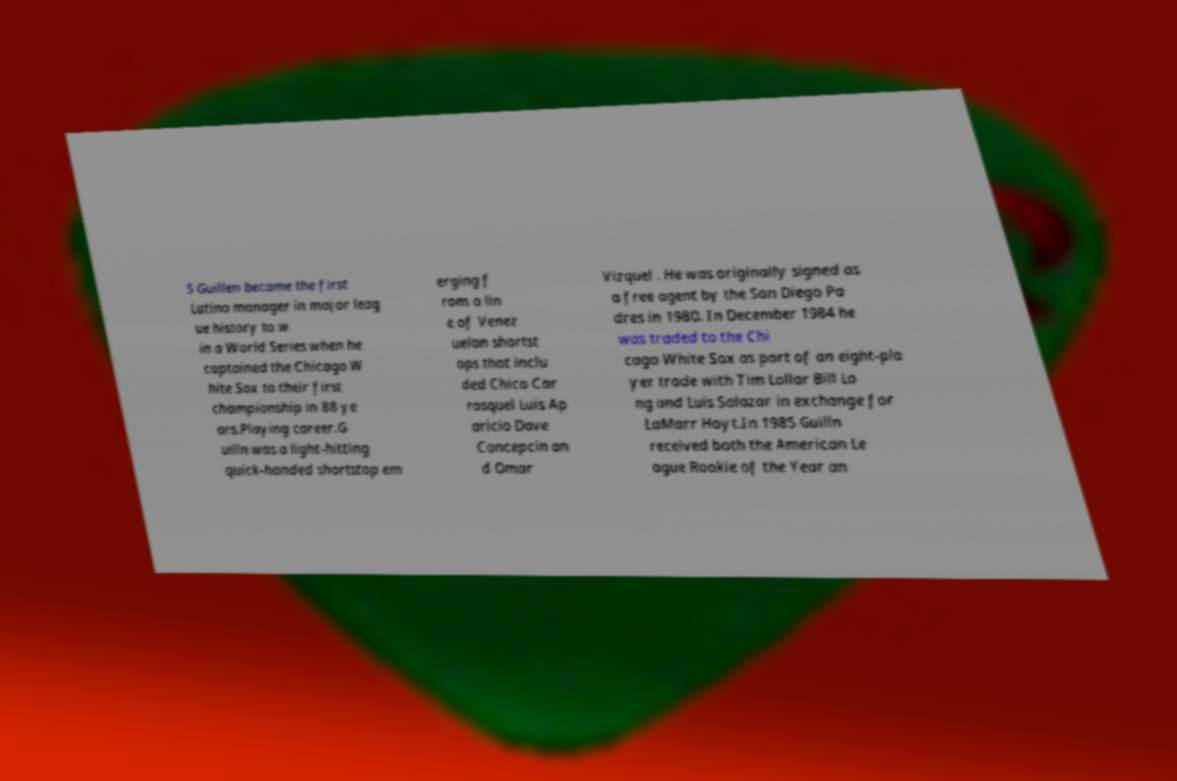What messages or text are displayed in this image? I need them in a readable, typed format. 5 Guillen became the first Latino manager in major leag ue history to w in a World Series when he captained the Chicago W hite Sox to their first championship in 88 ye ars.Playing career.G uilln was a light-hitting quick-handed shortstop em erging f rom a lin e of Venez uelan shortst ops that inclu ded Chico Car rasquel Luis Ap aricio Dave Concepcin an d Omar Vizquel . He was originally signed as a free agent by the San Diego Pa dres in 1980. In December 1984 he was traded to the Chi cago White Sox as part of an eight-pla yer trade with Tim Lollar Bill Lo ng and Luis Salazar in exchange for LaMarr Hoyt.In 1985 Guilln received both the American Le ague Rookie of the Year an 